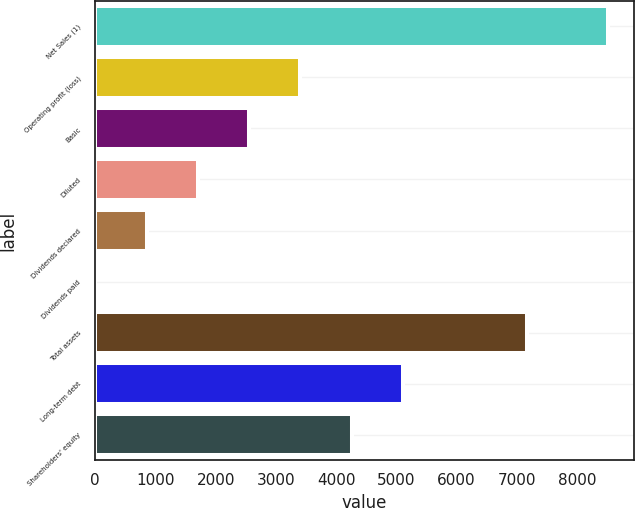Convert chart to OTSL. <chart><loc_0><loc_0><loc_500><loc_500><bar_chart><fcel>Net Sales (1)<fcel>Operating profit (loss)<fcel>Basic<fcel>Diluted<fcel>Dividends declared<fcel>Dividends paid<fcel>Total assets<fcel>Long-term debt<fcel>Shareholders' equity<nl><fcel>8521<fcel>3408.61<fcel>2556.54<fcel>1704.47<fcel>852.4<fcel>0.33<fcel>7167<fcel>5112.75<fcel>4260.68<nl></chart> 